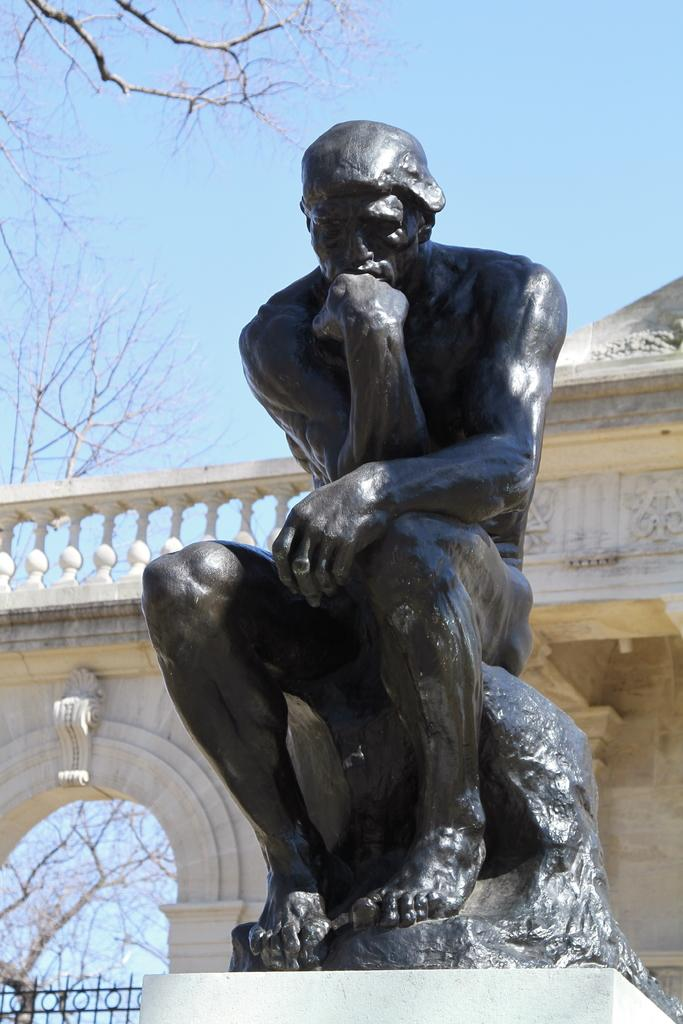What is the main subject in the center of the image? There is a statue in the center of the image. What can be seen in the background of the image? There is a building, railing, and trees in the background of the image. What is visible at the top of the image? The sky is visible at the top of the image. What unit of measurement is used to determine the acoustics of the statue in the image? There is no information about the acoustics of the statue in the image, and therefore no unit of measurement can be determined. 